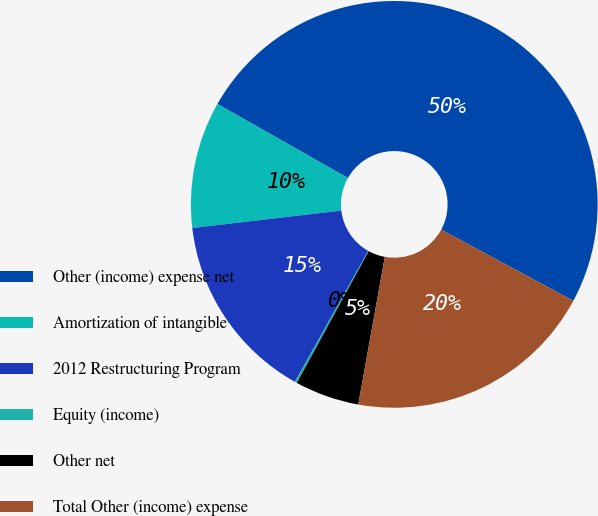Convert chart. <chart><loc_0><loc_0><loc_500><loc_500><pie_chart><fcel>Other (income) expense net<fcel>Amortization of intangible<fcel>2012 Restructuring Program<fcel>Equity (income)<fcel>Other net<fcel>Total Other (income) expense<nl><fcel>49.65%<fcel>10.07%<fcel>15.02%<fcel>0.17%<fcel>5.12%<fcel>19.97%<nl></chart> 